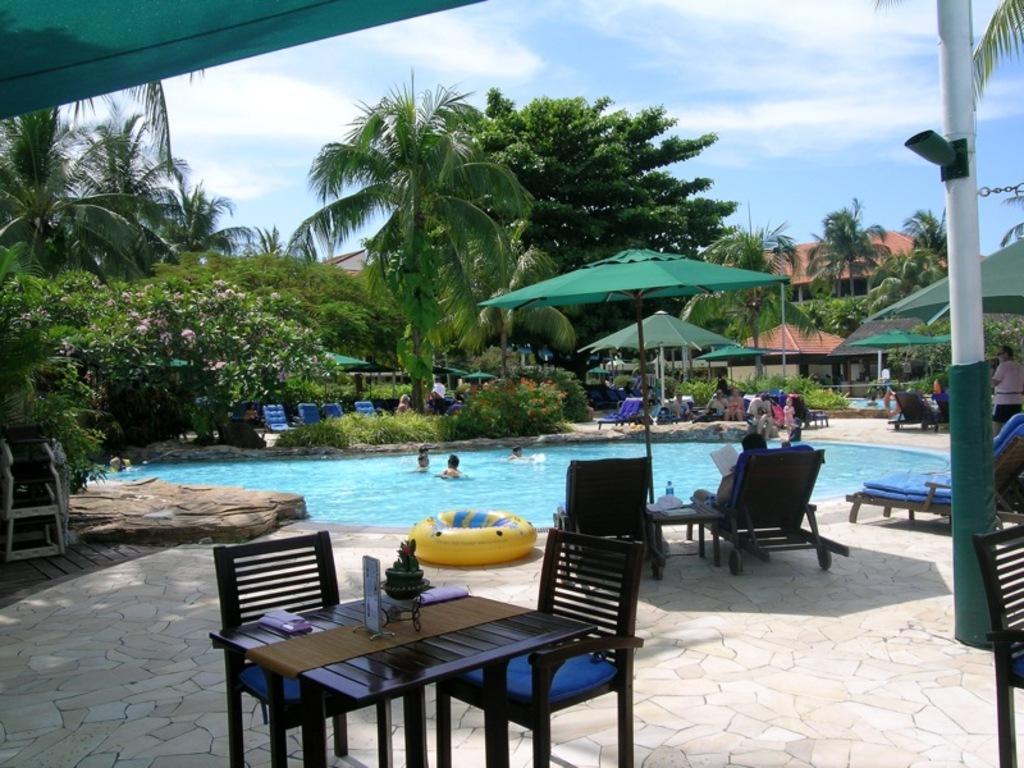Please provide a concise description of this image. In the center of the image we can see a pool which contains water. In pool we can see some persons, beside the pool we can see the plants, umbrellas, chairs. We can see some persons are sitting on the chairs. In the background of the image we can see the trees, buildings, roof, tables, chairs. On the table we can see some objects. At the bottom of the image we can see the floor. At the top of the image we can see the clouds are present in the sky. 